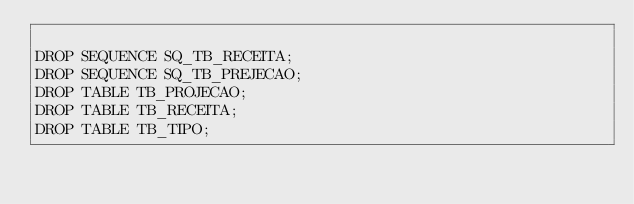Convert code to text. <code><loc_0><loc_0><loc_500><loc_500><_SQL_>
DROP SEQUENCE SQ_TB_RECEITA;
DROP SEQUENCE SQ_TB_PREJECAO;
DROP TABLE TB_PROJECAO;
DROP TABLE TB_RECEITA;
DROP TABLE TB_TIPO;
</code> 